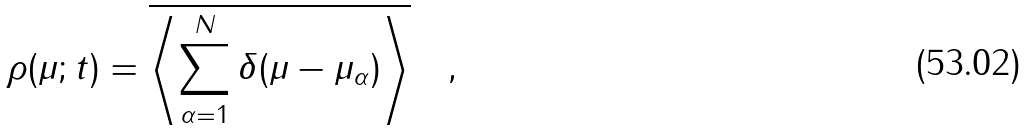Convert formula to latex. <formula><loc_0><loc_0><loc_500><loc_500>\rho ( \mu ; t ) = \overline { \left < \sum _ { \alpha = 1 } ^ { N } \delta ( \mu - \mu _ { \alpha } ) \right > } \quad ,</formula> 